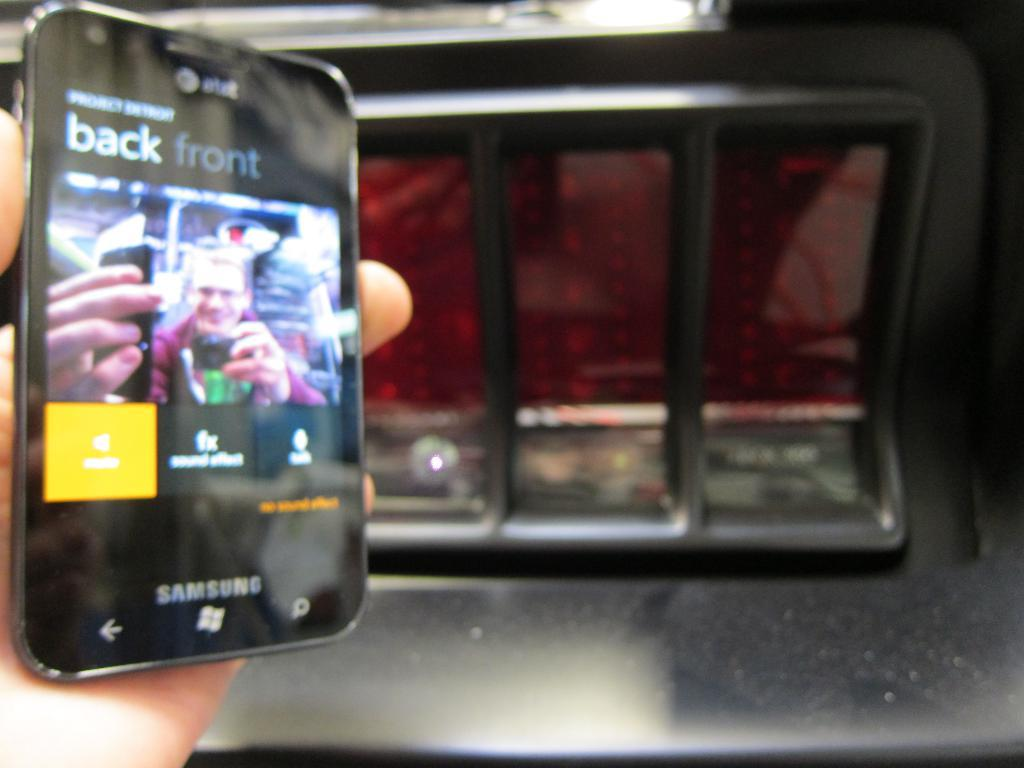<image>
Give a short and clear explanation of the subsequent image. A hand holding a black Samsung smart phone. 